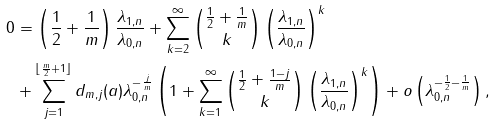Convert formula to latex. <formula><loc_0><loc_0><loc_500><loc_500>0 & = \left ( \frac { 1 } { 2 } + \frac { 1 } { m } \right ) \frac { \lambda _ { 1 , n } } { \lambda _ { 0 , n } } + \sum _ { k = 2 } ^ { \infty } { \frac { 1 } { 2 } + \frac { 1 } { m } \choose k } \left ( \frac { \lambda _ { 1 , n } } { \lambda _ { 0 , n } } \right ) ^ { k } \\ & + \sum _ { j = 1 } ^ { \lfloor \frac { m } { 2 } + 1 \rfloor } d _ { m , j } ( a ) \lambda _ { 0 , n } ^ { - \frac { j } { m } } \left ( 1 + \sum _ { k = 1 } ^ { \infty } { \frac { 1 } { 2 } + \frac { 1 - j } { m } \choose k } \left ( \frac { \lambda _ { 1 , n } } { \lambda _ { 0 , n } } \right ) ^ { k } \right ) + o \left ( \lambda _ { 0 , n } ^ { - \frac { 1 } { 2 } - \frac { 1 } { m } } \right ) ,</formula> 